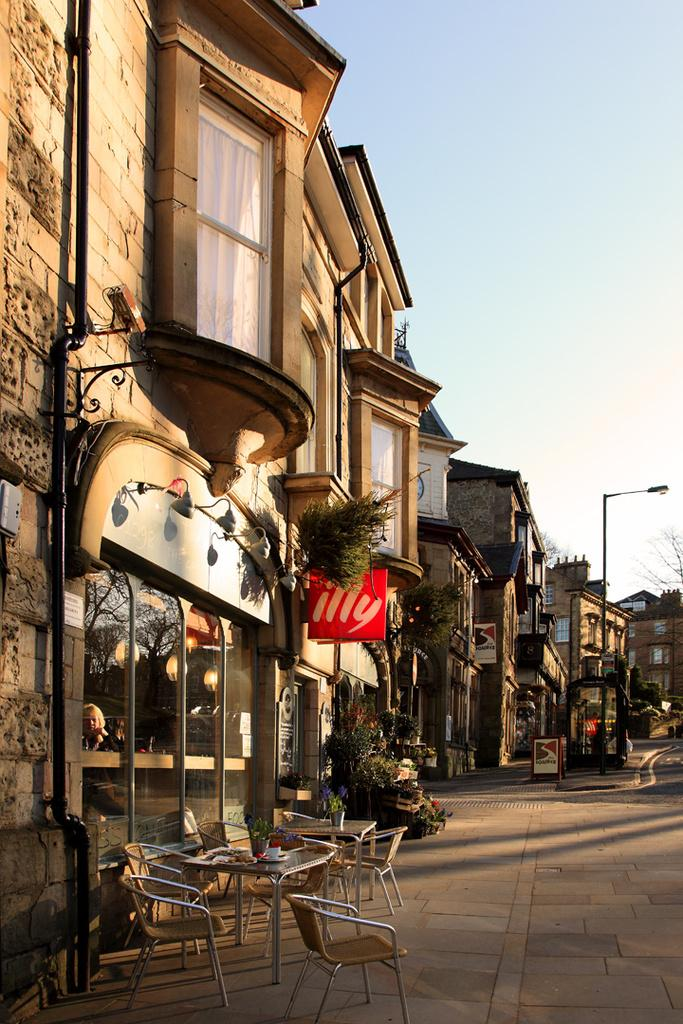What type of wealth can be seen in the image? There is no indication of wealth in the image, as it features chairs, tables, buildings, boards, flower pots, light poles, and the sky. What is the reason for the presence of the chairs and tables in the image? The image does not provide any information about the reason for the presence of the chairs and tables. Is there a prison visible in the image? No, there is no prison present in the image. What type of prison can be seen in the image? There is no prison present in the image; it features chairs, tables, buildings, boards, flower pots, light poles, and the sky. 